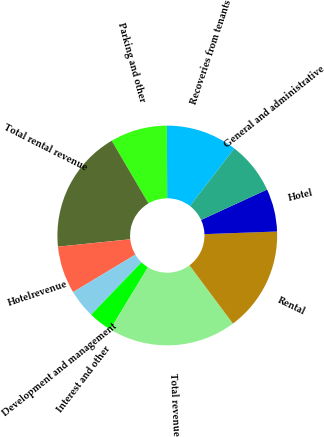Convert chart to OTSL. <chart><loc_0><loc_0><loc_500><loc_500><pie_chart><fcel>Recoveries from tenants<fcel>Parking and other<fcel>Total rental revenue<fcel>Hotelrevenue<fcel>Development and management<fcel>Interest and other<fcel>Total revenue<fcel>Rental<fcel>Hotel<fcel>General and administrative<nl><fcel>10.49%<fcel>8.39%<fcel>18.18%<fcel>6.99%<fcel>4.2%<fcel>3.5%<fcel>18.88%<fcel>15.38%<fcel>6.29%<fcel>7.69%<nl></chart> 